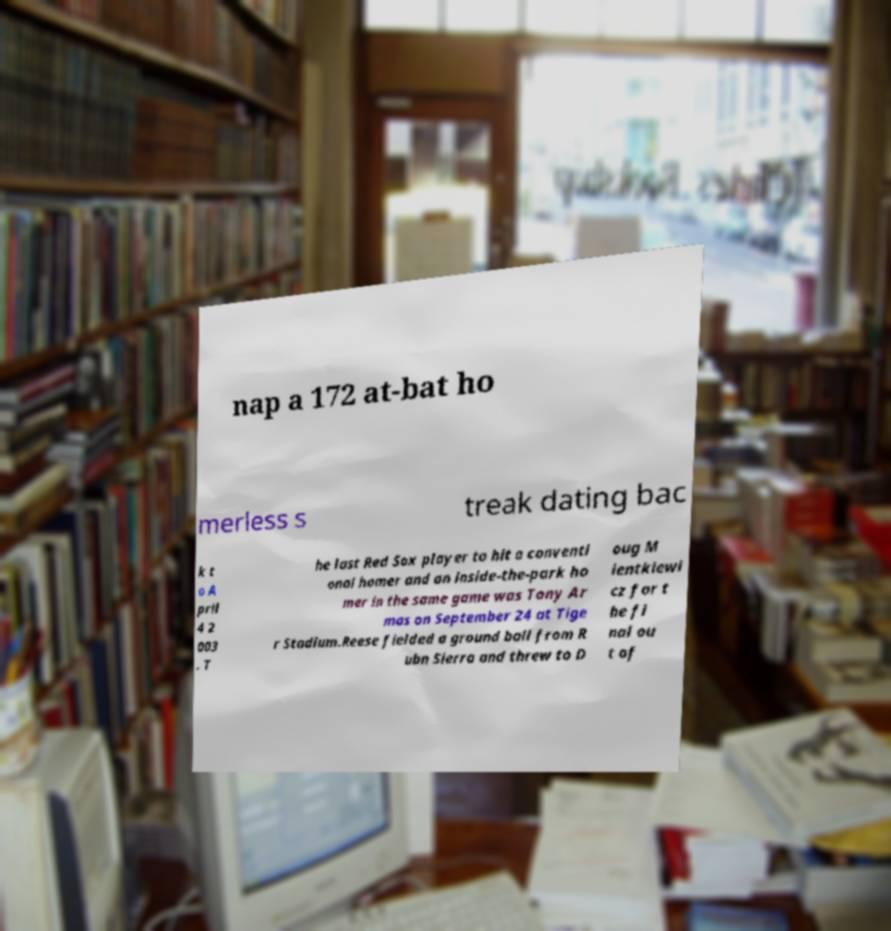Can you accurately transcribe the text from the provided image for me? nap a 172 at-bat ho merless s treak dating bac k t o A pril 4 2 003 . T he last Red Sox player to hit a conventi onal homer and an inside-the-park ho mer in the same game was Tony Ar mas on September 24 at Tige r Stadium.Reese fielded a ground ball from R ubn Sierra and threw to D oug M ientkiewi cz for t he fi nal ou t of 